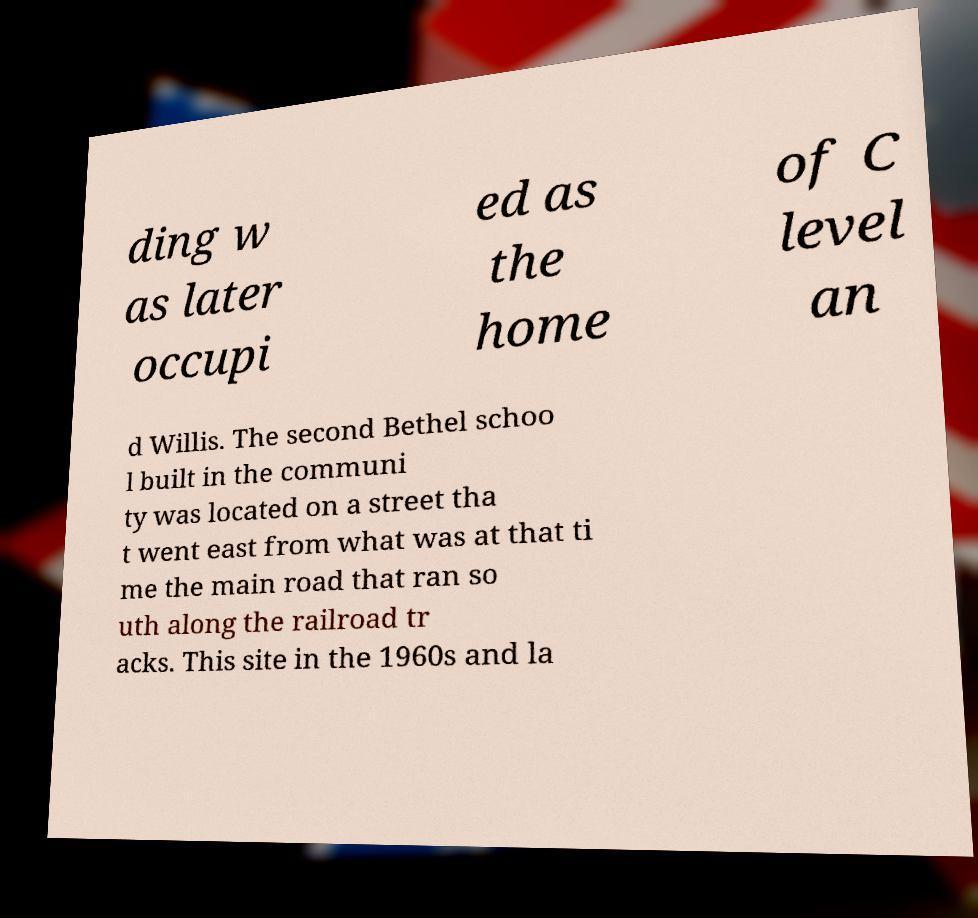There's text embedded in this image that I need extracted. Can you transcribe it verbatim? ding w as later occupi ed as the home of C level an d Willis. The second Bethel schoo l built in the communi ty was located on a street tha t went east from what was at that ti me the main road that ran so uth along the railroad tr acks. This site in the 1960s and la 